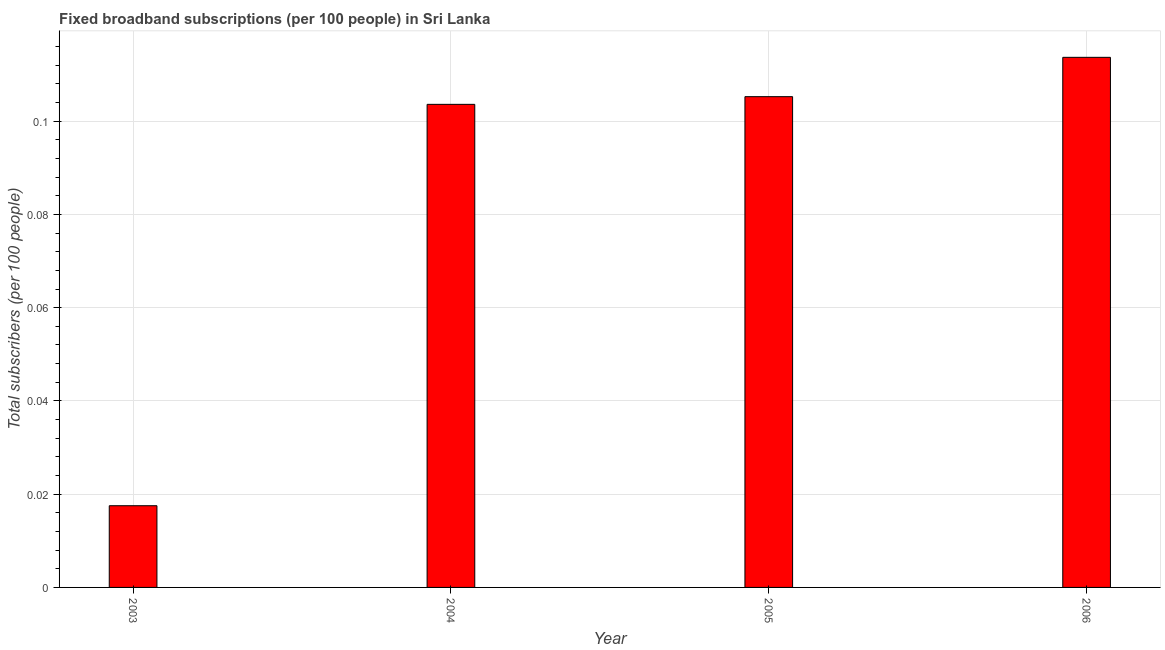Does the graph contain grids?
Ensure brevity in your answer.  Yes. What is the title of the graph?
Provide a succinct answer. Fixed broadband subscriptions (per 100 people) in Sri Lanka. What is the label or title of the X-axis?
Offer a very short reply. Year. What is the label or title of the Y-axis?
Provide a short and direct response. Total subscribers (per 100 people). What is the total number of fixed broadband subscriptions in 2006?
Provide a short and direct response. 0.11. Across all years, what is the maximum total number of fixed broadband subscriptions?
Keep it short and to the point. 0.11. Across all years, what is the minimum total number of fixed broadband subscriptions?
Make the answer very short. 0.02. In which year was the total number of fixed broadband subscriptions maximum?
Keep it short and to the point. 2006. In which year was the total number of fixed broadband subscriptions minimum?
Give a very brief answer. 2003. What is the sum of the total number of fixed broadband subscriptions?
Your response must be concise. 0.34. What is the difference between the total number of fixed broadband subscriptions in 2004 and 2006?
Your answer should be compact. -0.01. What is the average total number of fixed broadband subscriptions per year?
Offer a very short reply. 0.09. What is the median total number of fixed broadband subscriptions?
Offer a very short reply. 0.1. In how many years, is the total number of fixed broadband subscriptions greater than 0.072 ?
Your answer should be compact. 3. What is the ratio of the total number of fixed broadband subscriptions in 2005 to that in 2006?
Make the answer very short. 0.93. What is the difference between the highest and the second highest total number of fixed broadband subscriptions?
Offer a very short reply. 0.01. Is the sum of the total number of fixed broadband subscriptions in 2004 and 2005 greater than the maximum total number of fixed broadband subscriptions across all years?
Your response must be concise. Yes. What is the difference between the highest and the lowest total number of fixed broadband subscriptions?
Provide a succinct answer. 0.1. In how many years, is the total number of fixed broadband subscriptions greater than the average total number of fixed broadband subscriptions taken over all years?
Ensure brevity in your answer.  3. How many bars are there?
Ensure brevity in your answer.  4. How many years are there in the graph?
Provide a succinct answer. 4. What is the difference between two consecutive major ticks on the Y-axis?
Offer a terse response. 0.02. What is the Total subscribers (per 100 people) in 2003?
Your answer should be very brief. 0.02. What is the Total subscribers (per 100 people) in 2004?
Make the answer very short. 0.1. What is the Total subscribers (per 100 people) in 2005?
Your answer should be compact. 0.11. What is the Total subscribers (per 100 people) of 2006?
Your answer should be very brief. 0.11. What is the difference between the Total subscribers (per 100 people) in 2003 and 2004?
Offer a terse response. -0.09. What is the difference between the Total subscribers (per 100 people) in 2003 and 2005?
Your answer should be compact. -0.09. What is the difference between the Total subscribers (per 100 people) in 2003 and 2006?
Your response must be concise. -0.1. What is the difference between the Total subscribers (per 100 people) in 2004 and 2005?
Give a very brief answer. -0. What is the difference between the Total subscribers (per 100 people) in 2004 and 2006?
Make the answer very short. -0.01. What is the difference between the Total subscribers (per 100 people) in 2005 and 2006?
Ensure brevity in your answer.  -0.01. What is the ratio of the Total subscribers (per 100 people) in 2003 to that in 2004?
Your answer should be very brief. 0.17. What is the ratio of the Total subscribers (per 100 people) in 2003 to that in 2005?
Your response must be concise. 0.17. What is the ratio of the Total subscribers (per 100 people) in 2003 to that in 2006?
Your answer should be compact. 0.15. What is the ratio of the Total subscribers (per 100 people) in 2004 to that in 2006?
Ensure brevity in your answer.  0.91. What is the ratio of the Total subscribers (per 100 people) in 2005 to that in 2006?
Make the answer very short. 0.93. 